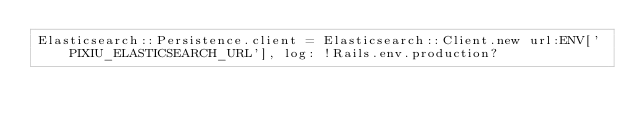Convert code to text. <code><loc_0><loc_0><loc_500><loc_500><_Ruby_>Elasticsearch::Persistence.client = Elasticsearch::Client.new url:ENV['PIXIU_ELASTICSEARCH_URL'], log: !Rails.env.production?</code> 